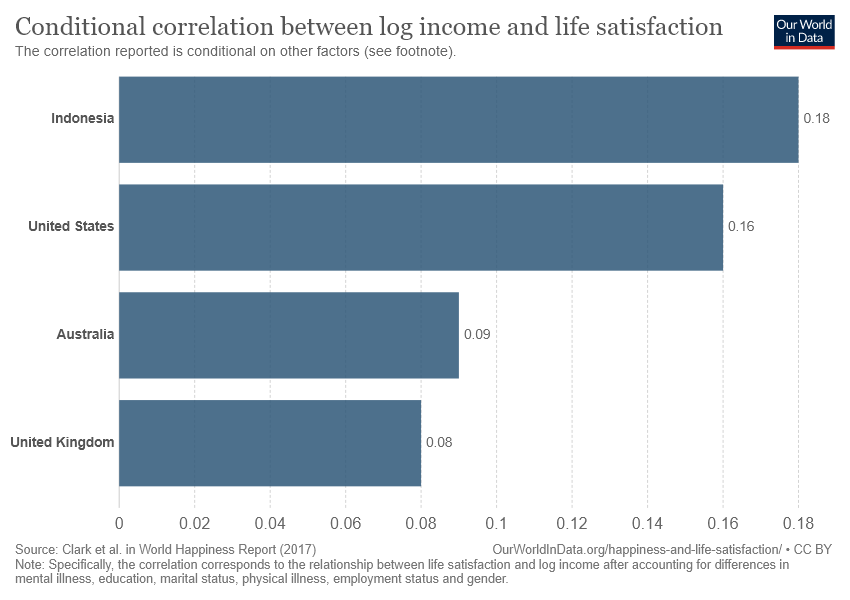Specify some key components in this picture. The total value of the United Kingdom and Australia is 0.17. The value of the largest bar is 0.18, according to the provided data. 